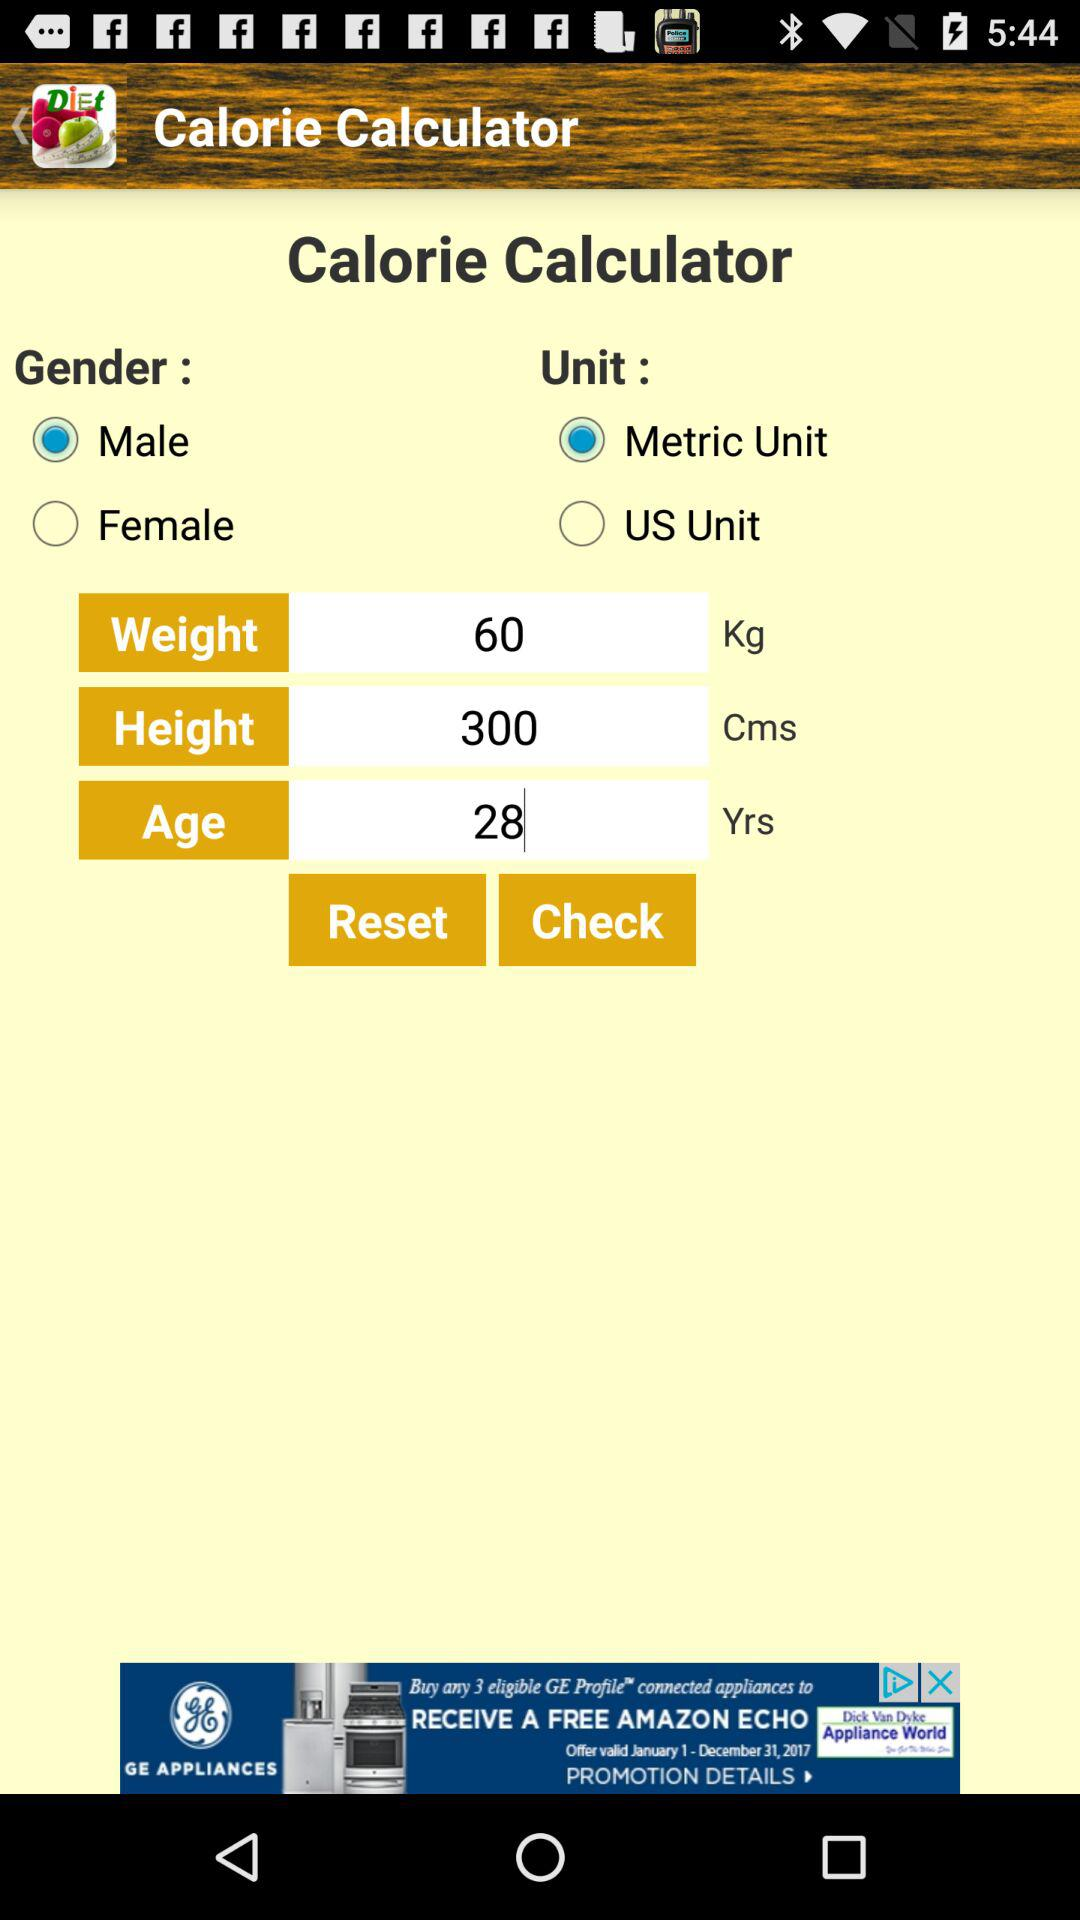What is the entered age? The entered age is 28 years. 